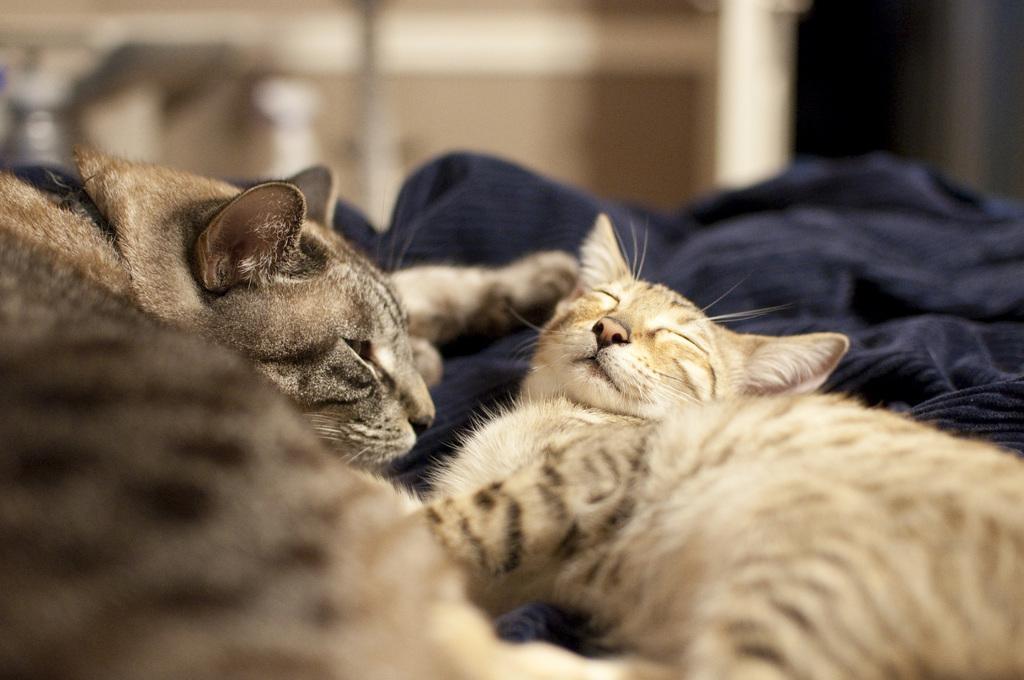Can you describe this image briefly? In this image I can see a cat which is cream, brown and black in color and another cat which is black, ash and cream in color are laying on the black colored cloth. I can see the blurry background. 